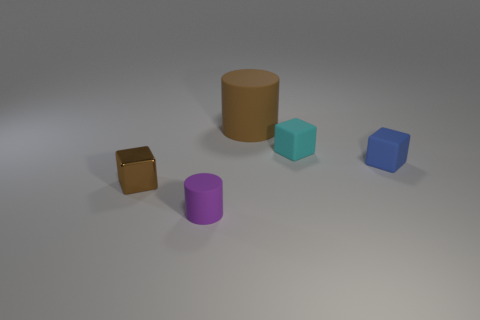Add 3 tiny brown things. How many objects exist? 8 Subtract all cubes. How many objects are left? 2 Subtract all large cyan cylinders. Subtract all small objects. How many objects are left? 1 Add 1 purple cylinders. How many purple cylinders are left? 2 Add 1 cyan balls. How many cyan balls exist? 1 Subtract 0 red cylinders. How many objects are left? 5 